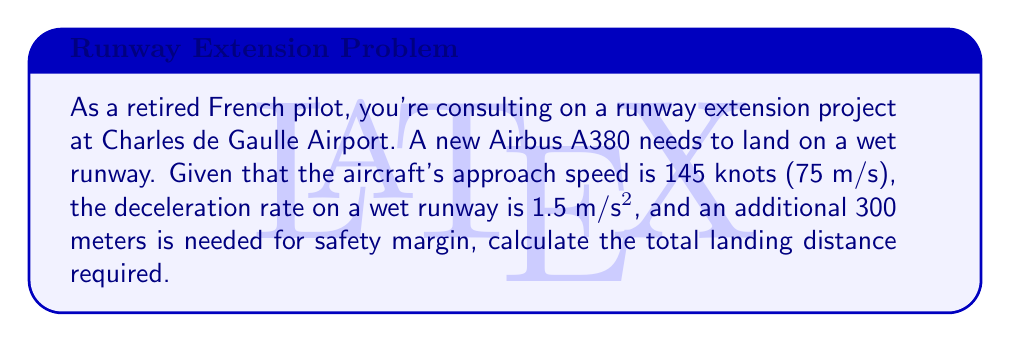Can you answer this question? Let's approach this step-by-step:

1) First, we need to use the kinematic equation that relates velocity, acceleration, and distance:

   $$v^2 = u^2 + 2as$$

   Where:
   $v$ = final velocity (0 m/s, as the aircraft comes to a stop)
   $u$ = initial velocity (75 m/s)
   $a$ = deceleration (-1.5 m/s², negative because it's slowing down)
   $s$ = distance traveled

2) Substituting these values:

   $$0^2 = 75^2 + 2(-1.5)s$$

3) Simplifying:

   $$0 = 5625 - 3s$$

4) Solving for s:

   $$3s = 5625$$
   $$s = 1875\text{ meters}$$

5) This is the distance needed for the aircraft to come to a stop. However, we need to add the safety margin:

   $$\text{Total distance} = 1875 + 300 = 2175\text{ meters}$$

Therefore, the total landing distance required is 2175 meters.
Answer: 2175 meters 